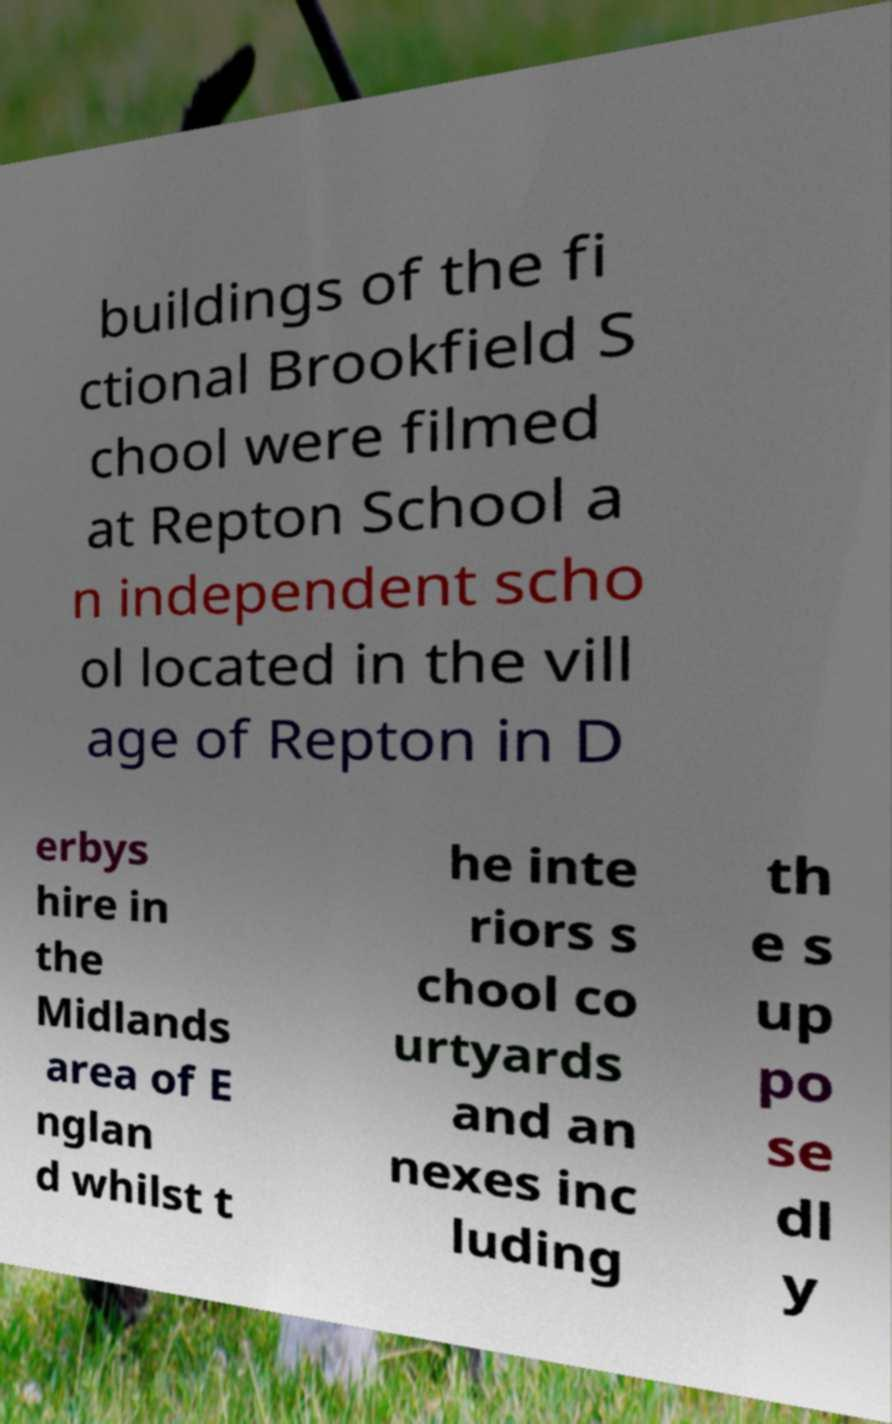There's text embedded in this image that I need extracted. Can you transcribe it verbatim? buildings of the fi ctional Brookfield S chool were filmed at Repton School a n independent scho ol located in the vill age of Repton in D erbys hire in the Midlands area of E nglan d whilst t he inte riors s chool co urtyards and an nexes inc luding th e s up po se dl y 